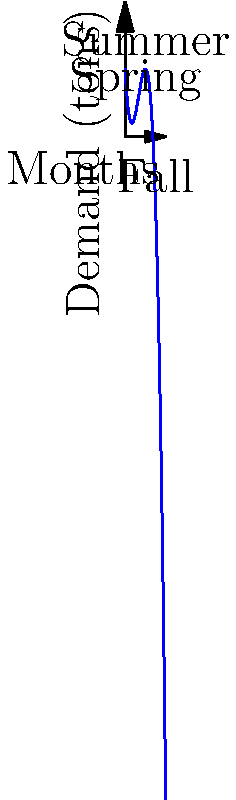The polynomial function $f(x) = -0.5x^3 + 6x^2 - 18x + 20$ represents the seasonal demand (in tons) for locally grown organic tomatoes, where $x$ represents the month (1 = January, 12 = December). Based on the graph, during which season does the demand for organic tomatoes peak, and approximately how many tons are demanded at this peak? To solve this problem, let's follow these steps:

1) First, we need to identify the seasons on the graph:
   - Spring: around month 3 (March)
   - Summer: around month 6 (June)
   - Fall: around month 9 (September)

2) Looking at the graph, we can see that the curve reaches its highest point during the summer months.

3) To find the exact peak, we need to find the maximum of the function. In calculus, this would involve finding where the derivative equals zero, but we can approximate from the graph.

4) The peak appears to occur slightly before the middle of summer, around month 5-6 (May-June).

5) To estimate the demand at the peak, we can look at the y-axis. The highest point of the curve appears to be between 35 and 40 tons.

6) Therefore, the demand for organic tomatoes peaks in early summer (around June) at approximately 37-38 tons.

This aligns with the typical tomato growing season, where tomatoes are often harvested in abundance during the summer months.
Answer: Summer, approximately 38 tons 